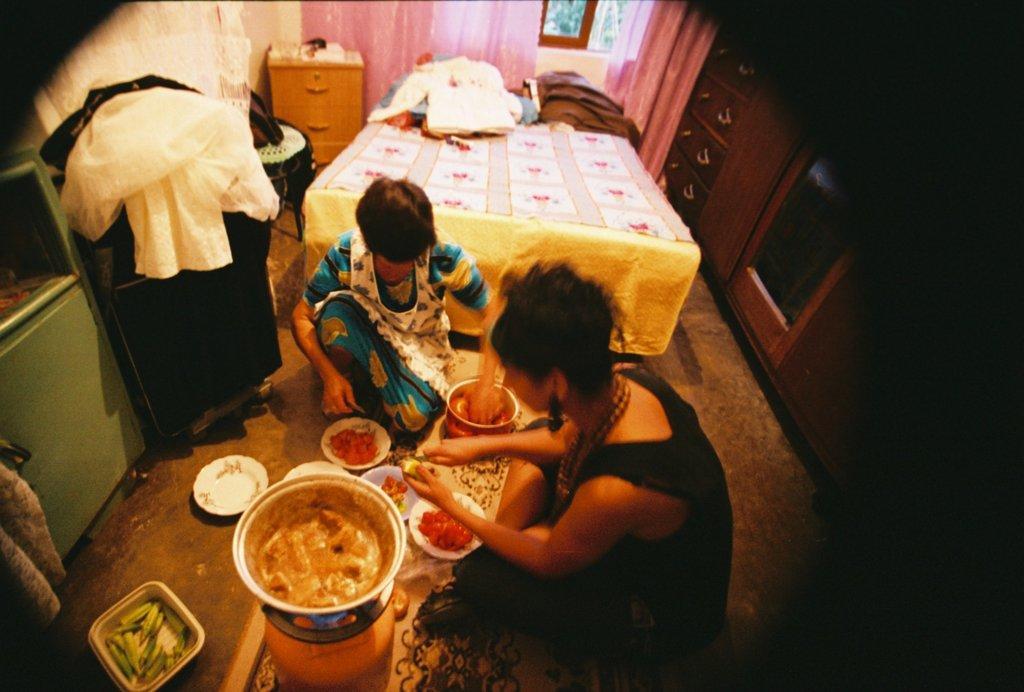Please provide a concise description of this image. This is an inside view of a room. Here I can see two women are sitting on the floor and looking at the vegetables. In front of these people there are some bowls and plates. on the plates I can see some vegetable slices. One woman is holding a knife in the hand and cutting some object. Beside there is a bowl on the gas. On the left side there is a table on which I can see a white color cloth. On the right side there is a cupboard. In the background, I can see a bed on which I can see some clothes. In the background there is a wall, table and a window. 